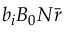<formula> <loc_0><loc_0><loc_500><loc_500>b _ { i } B _ { 0 } N \bar { r }</formula> 